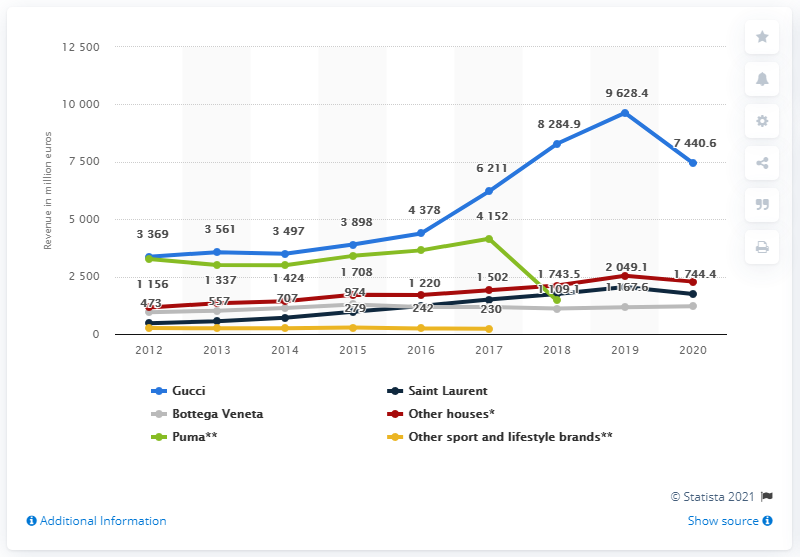Specify some key components in this picture. Kering's Gucci brand generated global revenue of 7440.6 million in 2020. 